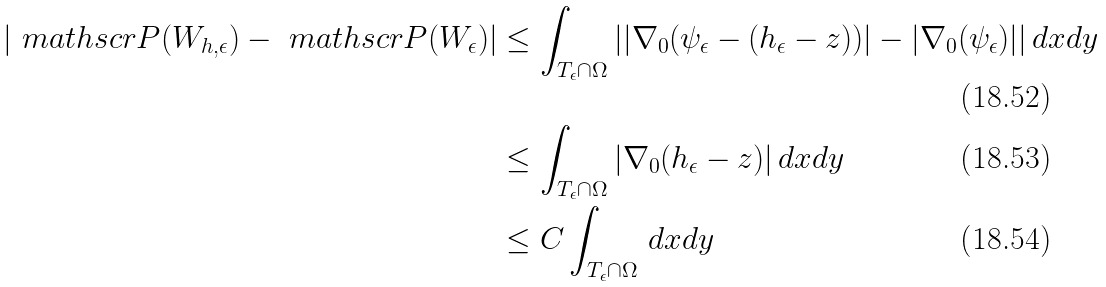<formula> <loc_0><loc_0><loc_500><loc_500>| \ m a t h s c r { P } ( W _ { h , \epsilon } ) - \ m a t h s c r { P } ( W _ { \epsilon } ) | & \leq \int _ { T _ { \epsilon } \cap \Omega } | | \nabla _ { 0 } ( \psi _ { \epsilon } - ( h _ { \epsilon } - z ) ) | - | \nabla _ { 0 } ( \psi _ { \epsilon } ) | | \, d x d y \\ & \leq \int _ { T _ { \epsilon } \cap \Omega } | \nabla _ { 0 } ( h _ { \epsilon } - z ) | \, d x d y \\ & \leq C \int _ { T _ { \epsilon } \cap \Omega } \, d x d y</formula> 